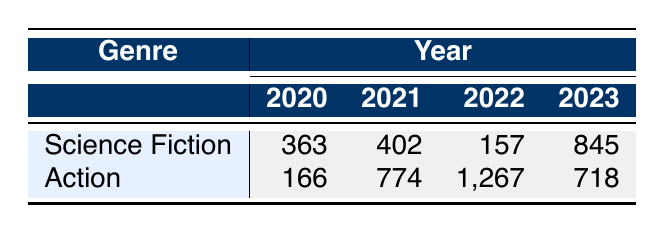What was the box office revenue for "Dune" in 2021? The table shows that "Dune," which belongs to the Science Fiction genre, had a box office revenue of 402 million in 2021.
Answer: 402 million Which genre had the highest revenue in 2022? According to the table, the Action genre had a revenue of 1,267 million in 2022, while Science Fiction had 157 million. Therefore, Action had the highest revenue that year.
Answer: Action What is the total revenue for Science Fiction films from 2020 to 2023? The respective revenues for Science Fiction films in those years are 363 million (2020), 402 million (2021), 157 million (2022), and 845 million (2023). Summing these values gives 363 + 402 + 157 + 845 = 1767 million.
Answer: 1767 million Which year saw the lowest revenue for the Action genre? Looking at the Action genre entries in the table, the revenues are 166 million (2020), 774 million (2021), 1,267 million (2022), and 718 million (2023). The lowest revenue is 166 million in 2020.
Answer: 2020 Was "Fast X" more successful than "No Time to Die" based on box office revenue? "Fast X" generated 718 million in 2023, while "No Time to Die" earned 774 million in 2021. Since 718 million is less than 774 million, "Fast X" was not more successful than "No Time to Die."
Answer: No What is the average revenue of Action films across all years listed? The revenues for Action films are 166 million (2020), 774 million (2021), 1,267 million (2022), and 718 million (2023). The total revenue is 166 + 774 + 1,267 + 718 = 2,925 million. The number of years is 4, so the average is 2,925 / 4 = 731.25 million.
Answer: 731.25 million In how many years did Science Fiction films earn over 400 million? Referring to the Science Fiction entries, the relevant revenues are 363 million (2020), 402 million (2021), 157 million (2022), and 845 million (2023). Only 2021 and 2023 exceeded 400 million, leading to a count of 2 years.
Answer: 2 years Which film had the highest box office revenue in 2023? Reviewing the revenues for 2023, "Guardians of the Galaxy Vol. 3" earned 845 million while "Fast X" earned 718 million. Therefore, "Guardians of the Galaxy Vol. 3" was the highest.
Answer: Guardians of the Galaxy Vol. 3 What was the change in revenue for Science Fiction films from 2021 to 2022? In 2021, the revenue was 402 million, and in 2022 it decreased to 157 million. The difference is 402 - 157 = 245 million, indicating a decrease.
Answer: Decrease of 245 million 